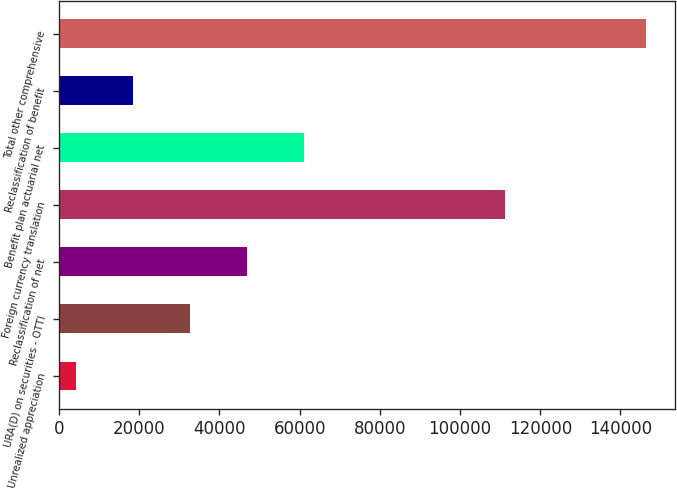<chart> <loc_0><loc_0><loc_500><loc_500><bar_chart><fcel>Unrealized appreciation<fcel>URA(D) on securities - OTTI<fcel>Reclassification of net<fcel>Foreign currency translation<fcel>Benefit plan actuarial net<fcel>Reclassification of benefit<fcel>Total other comprehensive<nl><fcel>4278<fcel>32693.4<fcel>46901.1<fcel>111145<fcel>61108.8<fcel>18485.7<fcel>146355<nl></chart> 